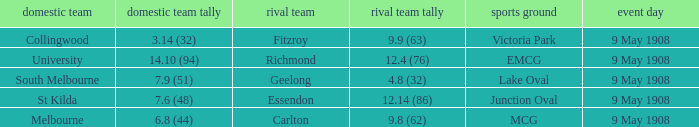Name the away team score for lake oval 4.8 (32). 